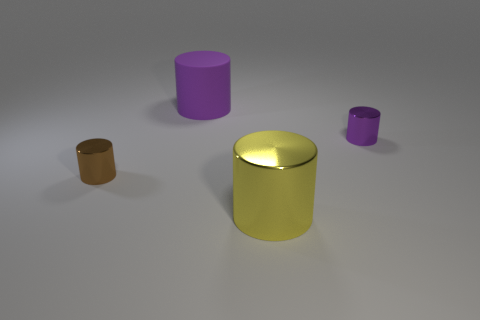How many other objects are there of the same material as the big purple cylinder?
Your answer should be compact. 0. What shape is the tiny purple shiny object behind the tiny object that is on the left side of the big cylinder in front of the purple rubber object?
Make the answer very short. Cylinder. What is the size of the shiny object that is behind the yellow metal cylinder and in front of the purple metallic cylinder?
Give a very brief answer. Small. What number of large shiny cylinders have the same color as the large rubber cylinder?
Keep it short and to the point. 0. What is the material of the small object that is the same color as the large rubber cylinder?
Your response must be concise. Metal. What is the small purple cylinder made of?
Provide a short and direct response. Metal. Does the small cylinder that is behind the small brown object have the same material as the large purple thing?
Your response must be concise. No. What shape is the shiny object that is right of the large metallic cylinder?
Your answer should be very brief. Cylinder. There is a purple cylinder that is the same size as the yellow shiny cylinder; what is its material?
Provide a succinct answer. Rubber. What number of objects are either large objects that are right of the large purple cylinder or small cylinders that are right of the big rubber cylinder?
Provide a short and direct response. 2. 